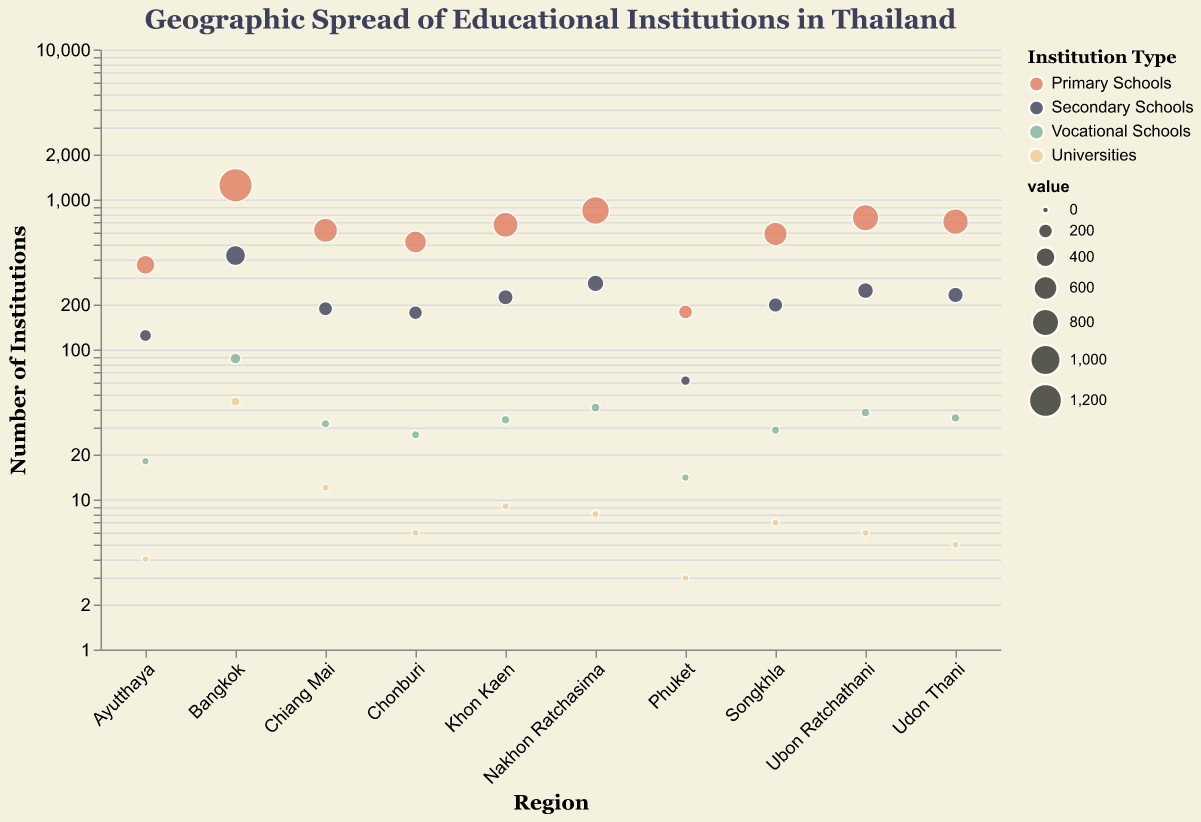Among the selected regions, which has the highest number of vocational schools? By examining each region's number of vocational schools, you will see that Bangkok has the highest with 87.
Answer: Bangkok What is the combined number of universities in Khon Kaen and Songkhla? Add the number of universities in Khon Kaen (9) and Songkhla (7). 9 + 7 = 16
Answer: 16 In Chonburi, how does the number of primary schools compare to secondary schools? Compare the values: Chonburi has 521 primary schools and 176 secondary schools. 521 is greater than 176.
Answer: More primary schools Which type of educational institution is the least common across all regions? Add up the numbers for each type of institution across all regions, and the least common one will have the smallest total.
Answer: Universities How many more primary schools are there in Nakhon Ratchasima than in Phuket? Subtract the number of primary schools in Phuket (178) from the number in Nakhon Ratchasima (845). 845 - 178 = 667
Answer: 667 Which region has a greater number of vocational schools than universities but fewer than secondary schools? Comparing the counts for each region's vocational schools and universities reveals that all regions meet this criterion. Compare to secondary schools to find total matches.
Answer: Multiple regions What is the average number of secondary schools in Udon Thani, Songkhla, and Ubon Ratchathani? Add the number of secondary schools in Udon Thani (231), Songkhla (198), and Ubon Ratchathani (247), then divide by 3. (231 + 198 + 247) / 3 = 676 / 3 ≈ 225
Answer: 225 